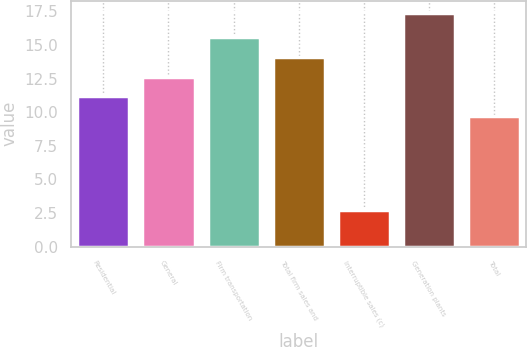Convert chart. <chart><loc_0><loc_0><loc_500><loc_500><bar_chart><fcel>Residential<fcel>General<fcel>Firm transportation<fcel>Total firm sales and<fcel>Interruptible sales (c)<fcel>Generation plants<fcel>Total<nl><fcel>11.17<fcel>12.64<fcel>15.6<fcel>14.11<fcel>2.7<fcel>17.4<fcel>9.7<nl></chart> 